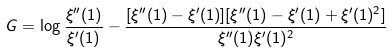<formula> <loc_0><loc_0><loc_500><loc_500>G = \log \frac { \xi ^ { \prime \prime } ( 1 ) } { \xi ^ { \prime } ( 1 ) } - \frac { [ \xi ^ { \prime \prime } ( 1 ) - \xi ^ { \prime } ( 1 ) ] [ \xi ^ { \prime \prime } ( 1 ) - \xi ^ { \prime } ( 1 ) + \xi ^ { \prime } ( 1 ) ^ { 2 } ] } { \xi ^ { \prime \prime } ( 1 ) \xi ^ { \prime } ( 1 ) ^ { 2 } }</formula> 